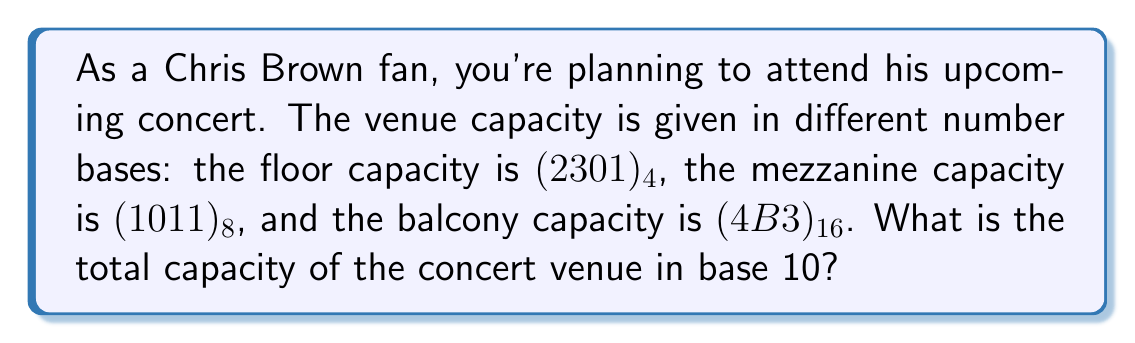What is the answer to this math problem? To solve this problem, we need to convert each capacity from its given base to base 10 and then sum them up.

1. Floor capacity: $(2301)_4$
   In base 4, each digit is multiplied by a power of 4 and then summed:
   $$(2301)_4 = 2 \cdot 4^3 + 3 \cdot 4^2 + 0 \cdot 4^1 + 1 \cdot 4^0$$
   $$= 2 \cdot 64 + 3 \cdot 16 + 0 \cdot 4 + 1 \cdot 1$$
   $$= 128 + 48 + 0 + 1 = 177_{10}$$

2. Mezzanine capacity: $(1011)_8$
   In base 8, each digit is multiplied by a power of 8 and then summed:
   $$(1011)_8 = 1 \cdot 8^3 + 0 \cdot 8^2 + 1 \cdot 8^1 + 1 \cdot 8^0$$
   $$= 1 \cdot 512 + 0 \cdot 64 + 1 \cdot 8 + 1 \cdot 1$$
   $$= 512 + 0 + 8 + 1 = 521_{10}$$

3. Balcony capacity: $(4B3)_{16}$
   In base 16, each digit is multiplied by a power of 16 and then summed. Note that B in hexadecimal is equal to 11 in decimal:
   $$(4B3)_{16} = 4 \cdot 16^2 + 11 \cdot 16^1 + 3 \cdot 16^0$$
   $$= 4 \cdot 256 + 11 \cdot 16 + 3 \cdot 1$$
   $$= 1024 + 176 + 3 = 1203_{10}$$

Now, we sum up all the capacities in base 10:
$$\text{Total capacity} = 177 + 521 + 1203 = 1901_{10}$$
Answer: The total capacity of the concert venue is $1901_{10}$ or 1,901 in standard decimal notation. 